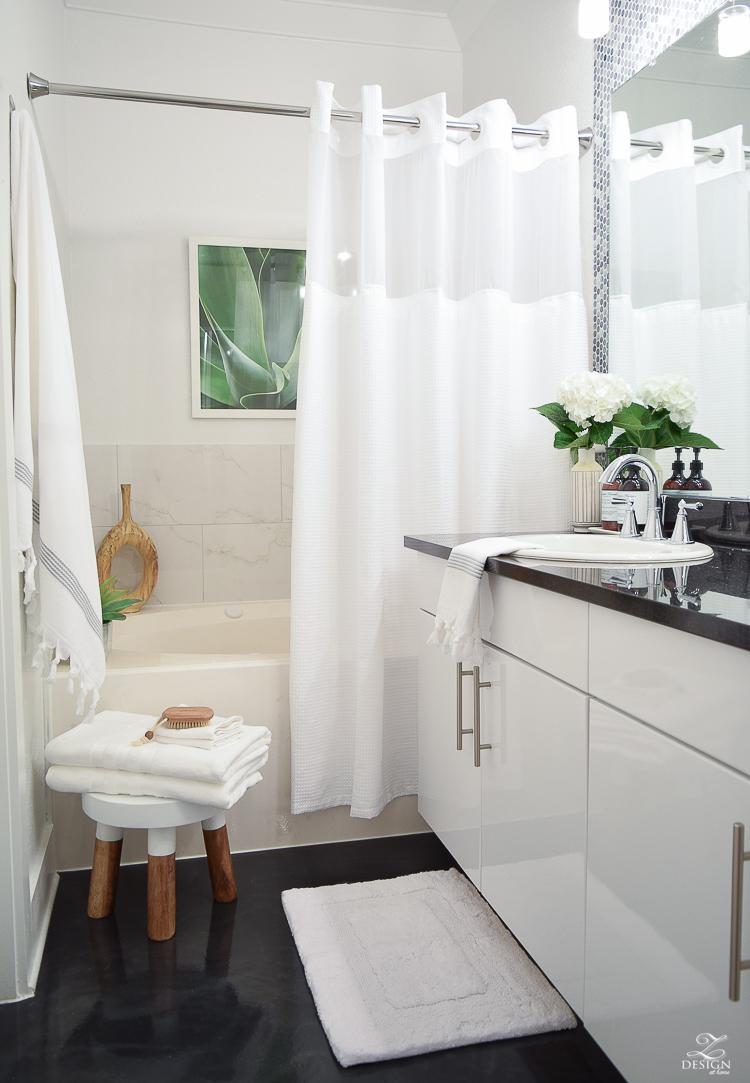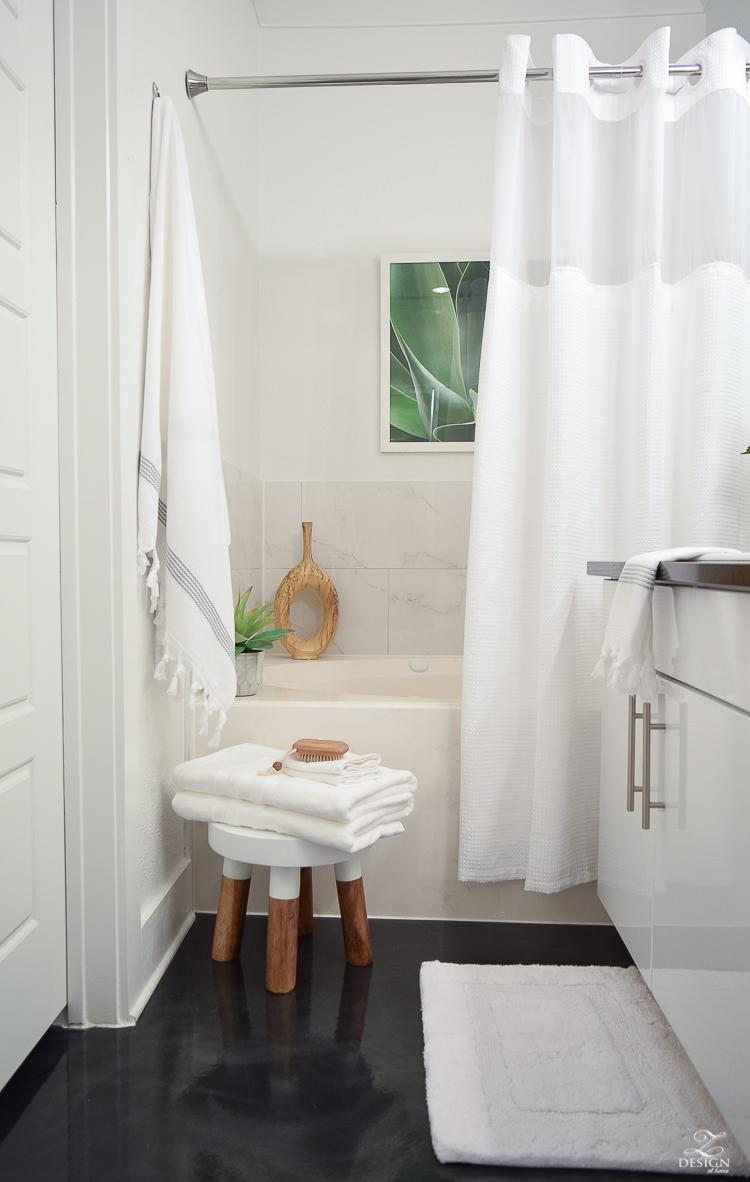The first image is the image on the left, the second image is the image on the right. Assess this claim about the two images: "The left and right image contains the same number folded towels.". Correct or not? Answer yes or no. Yes. The first image is the image on the left, the second image is the image on the right. Given the left and right images, does the statement "In the left image there are three folded towels stacked together." hold true? Answer yes or no. No. 